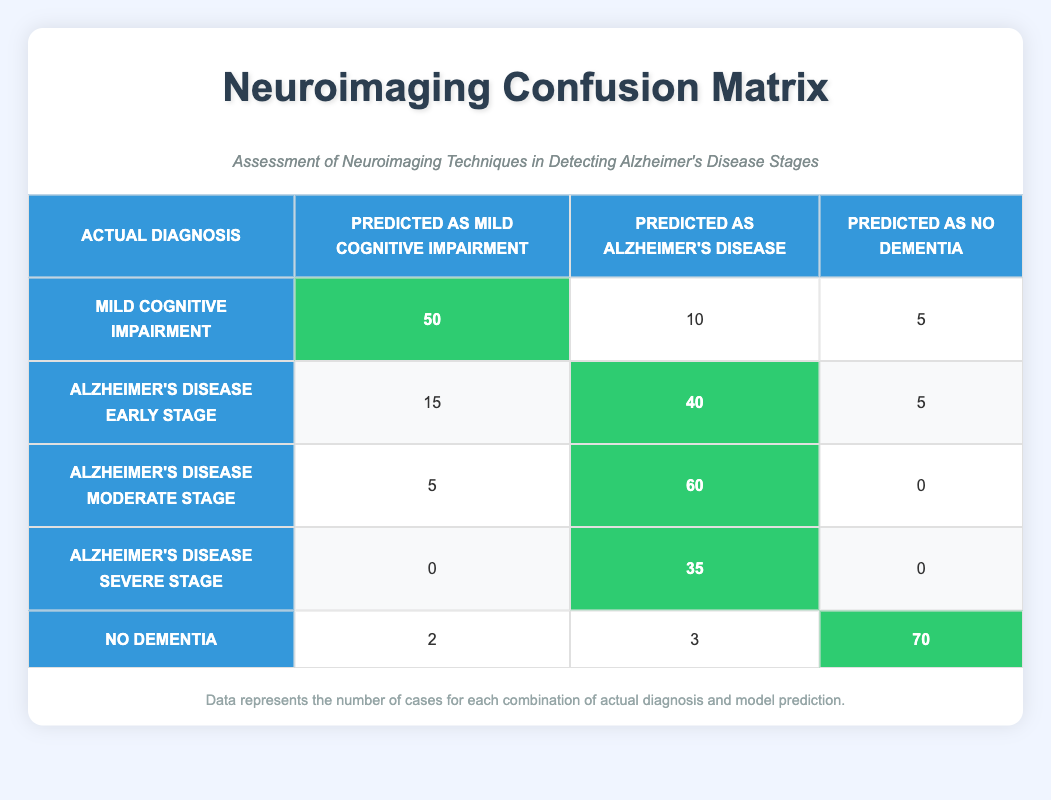What is the number of cases predicted as Mild Cognitive Impairment from the actual group of Alzheimer's Disease Early Stage? In the table, locate the row for "Alzheimer's Disease Early Stage." The corresponding value in the "Predicted as Mild Cognitive Impairment" column is 15.
Answer: 15 What is the total number of cases predicted as Alzheimer's Disease across all actual diagnosis groups? To find the total, sum all values in the "Predicted as Alzheimer's Disease" column: 10 (Mild Cognitive Impairment) + 40 (Alzheimer's Disease Early Stage) + 60 (Alzheimer's Disease Moderate Stage) + 35 (Alzheimer's Disease Severe Stage) + 3 (No Dementia) = 148.
Answer: 148 Is the number of actual No Dementia cases predicted as Mild Cognitive Impairment greater than those predicted as Alzheimer's Disease? According to the table, No Dementia cases predicted as Mild Cognitive Impairment is 2, while those predicted as Alzheimer's Disease is 3. Since 2 is not greater than 3, the answer is no.
Answer: No What percentage of cases from the actual Mild Cognitive Impairment diagnosis were correctly predicted as Mild Cognitive Impairment? From the table, there are 50 predicted as Mild Cognitive Impairment and 50 + 10 + 5 = 65 total cases for Mild Cognitive Impairment. The percentage is (50/65) * 100 = 76.92, rounded to two decimal places is approximately 76.92%.
Answer: 76.92% Which actual diagnosis group has the lowest number of cases predicted as No Dementia? Look at the "Predicted as No Dementia" column in the table. The corresponding values are 5 (Mild Cognitive Impairment), 5 (Alzheimer's Disease Early Stage), 0 (Alzheimer's Disease Moderate Stage), 0 (Alzheimer's Disease Severe Stage), and 70 (No Dementia). Both Alzheimer's Disease Moderate Stage and Severe Stage have the lowest value of 0.
Answer: Alzheimer's Disease Moderate Stage and Severe Stage 